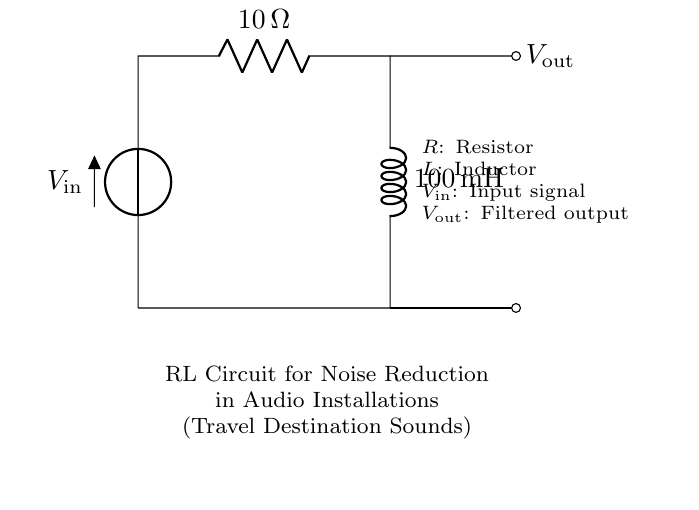What is the resistance value in this circuit? The resistance value is indicated next to the R component in the diagram as 10 Ohms.
Answer: 10 Ohms What is the inductance value in this circuit? The inductance value is shown next to the L component in the diagram, which states it is 100 millihenries.
Answer: 100 millihenries What does V_in represent in this circuit? V_in is labeled in the diagram as the input signal to the circuit, indicating the source of electrical power.
Answer: Input signal What is the purpose of this RL circuit? The diagram specifies that the purpose is noise reduction in audio installations, specifically for sounds from travel destinations, demonstrating its application in filtering.
Answer: Noise reduction How does adding the inductor help in this circuit? The inductor smooths the output from the circuit, helping to filter out high-frequency noise while allowing lower frequencies to pass, which is essential for audio clarity.
Answer: Smoothing output What happens to the output voltage when the resistance increases? Increasing the resistance typically will reduce the output voltage, as per Ohm's law, affected by the voltage drop across the resistor leading to less voltage at V_out.
Answer: Reduces output voltage What is the relationship between V_in and V_out? V_out is a filtered version of V_in; using the RL configuration, it is tuned to reduce unwanted noise, modifying the characteristics of the signal that is output.
Answer: Filtered version of V_in 